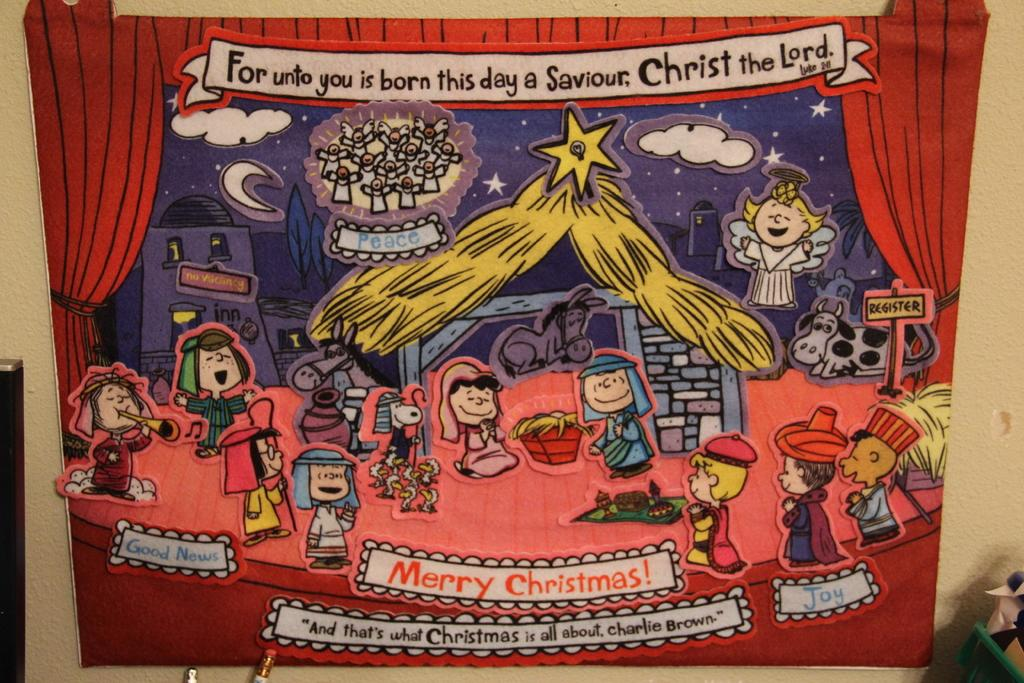<image>
Write a terse but informative summary of the picture. Charlie Brown poster saying Merry Christmas on it. 